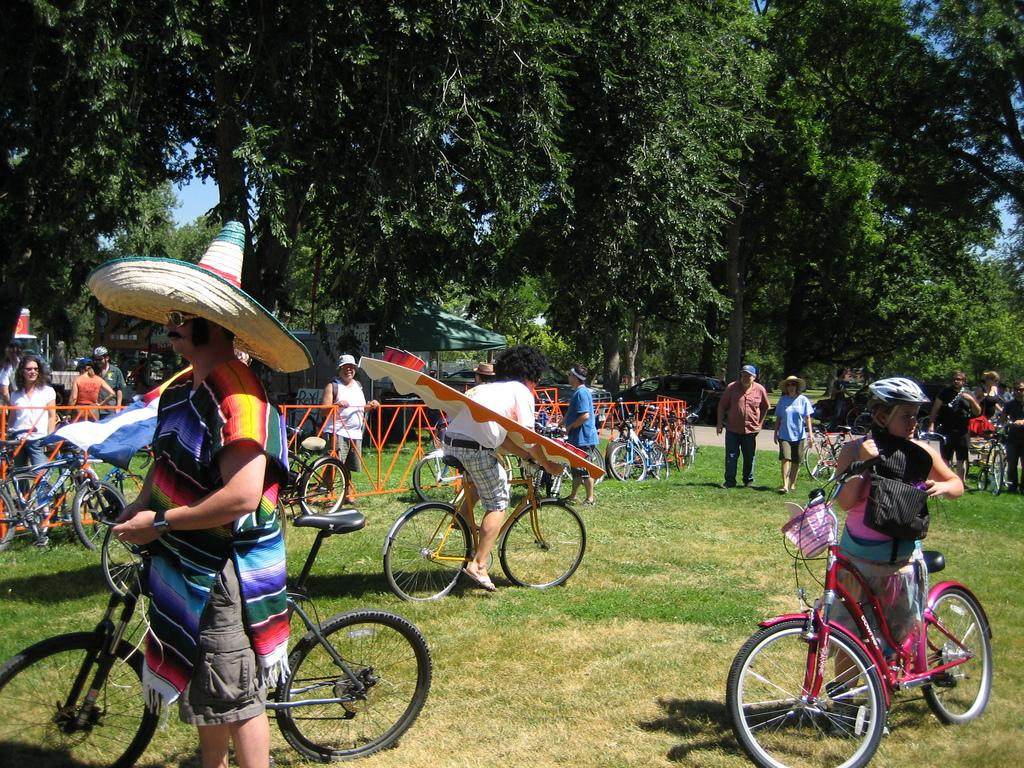What are the people in the image doing? The people in the image are riding bicycles. Where are the bicycles located? The bicycles are on the ground. What is in the middle of the image? There is a fence in the middle of the image. What can be seen in the background of the image? There are trees in the background of the image. What type of square can be seen on the side of the bicycle in the image? There is no square visible on the side of the bicycle in the image. What kind of band is playing music in the background of the image? There is no band present in the image; it only features people riding bicycles, a fence, and trees in the background. 